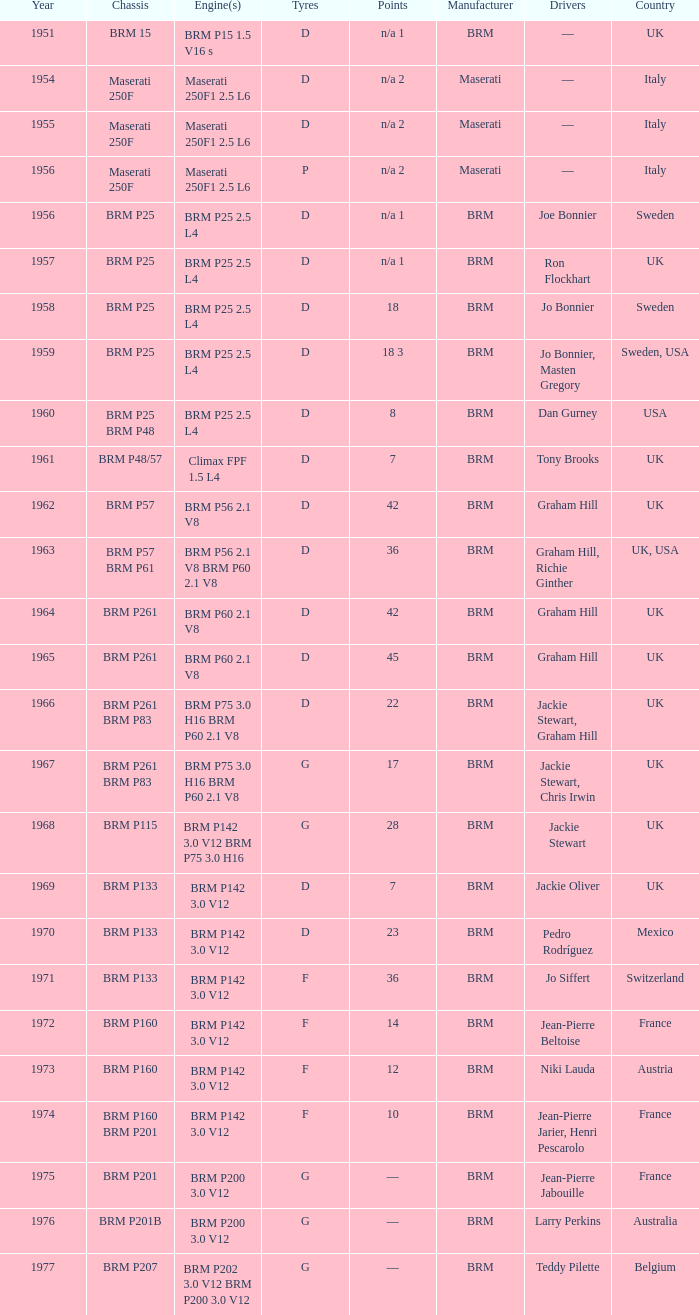Name the point for 1974 10.0. 